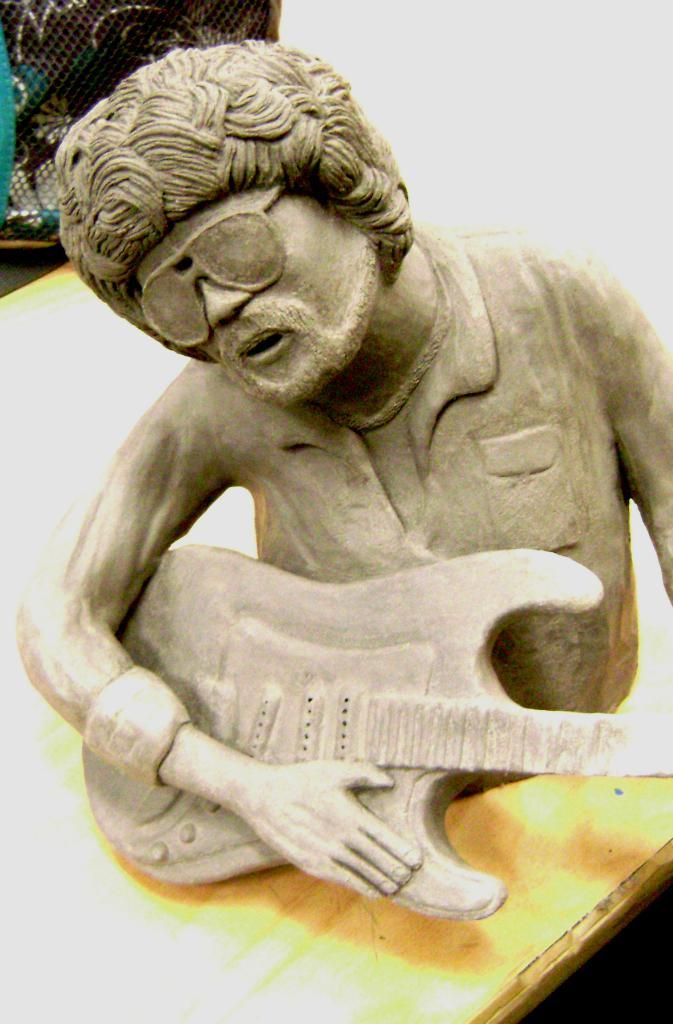What is the main subject of the image? There is a statue of a person in the image. What is the person holding in their hand? The person is holding a guitar in their hand. Can you describe any other objects visible in the image? Unfortunately, the provided facts do not mention any other objects visible in the image. How many pizzas are being pointed at by the statue in the image? There are no pizzas present in the image, and the statue is not pointing at anything. 